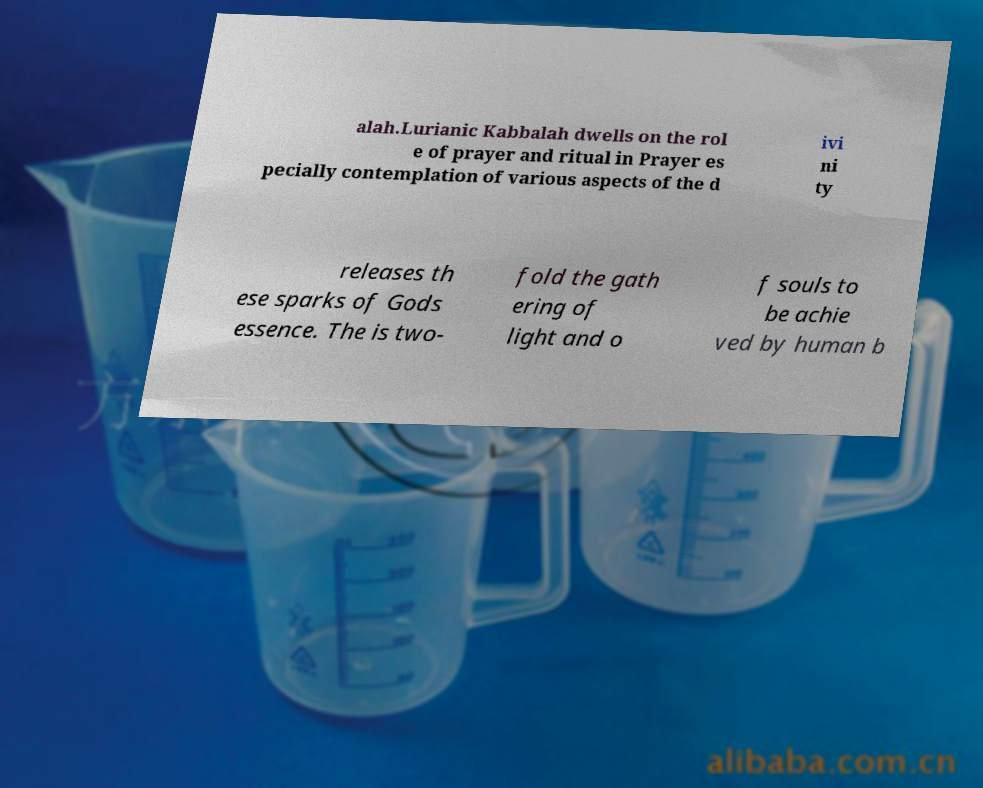Could you extract and type out the text from this image? alah.Lurianic Kabbalah dwells on the rol e of prayer and ritual in Prayer es pecially contemplation of various aspects of the d ivi ni ty releases th ese sparks of Gods essence. The is two- fold the gath ering of light and o f souls to be achie ved by human b 